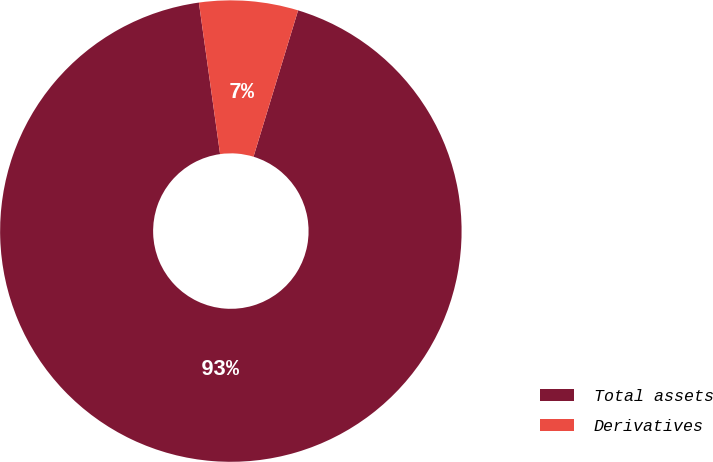Convert chart to OTSL. <chart><loc_0><loc_0><loc_500><loc_500><pie_chart><fcel>Total assets<fcel>Derivatives<nl><fcel>93.08%<fcel>6.92%<nl></chart> 